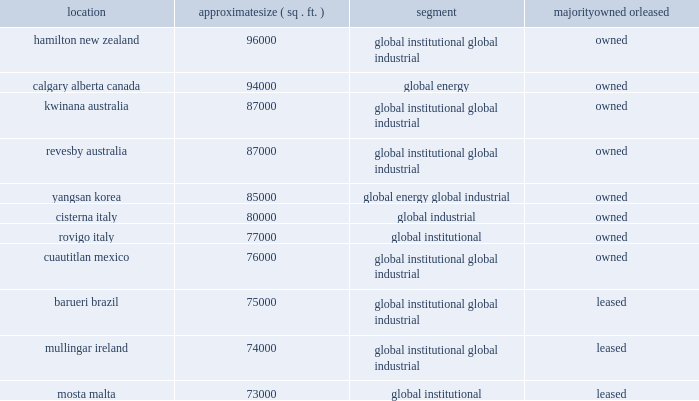Location approximate size ( sq .
Ft. ) segment majority owned or leased .
Generally , our manufacturing facilities are adequate to meet our existing in-house production needs .
We continue to invest in our plant sites to maintain viable operations and to add capacity as necessary to meet business imperatives .
Most of our manufacturing plants also serve as distribution centers .
In addition , we operate distribution centers around the world , most of which are leased , and utilize third party logistics service providers to facilitate the distribution of our products and services .
At year end 2016 ecolab 2019s corporate headquarters was comprised of three adjacent multi-storied buildings located in downtown st .
Paul , minnesota .
The main 19-story building was constructed to our specifications and is leased through june 30 , 2018 .
The second building is leased through 2019 .
The company intends to vacate the current leased buildings in 2018 .
The third building is owned .
Ecolab acquired the 17-story north tower from the travelers indemnity company in downtown st .
Paul , minnesota on august 4 , 2015 .
This building became the corporate headquarters in 2017 .
A 90 acre campus in eagan , minnesota is owned and provides for future growth .
The eagan facility houses a significant research and development center , a data center and training facilities as well as several of our administrative functions .
We also have a significant business presence in naperville , illinois , where our water and paper operating segment maintain their principal administrative offices and research center .
As discussed in part ii , item 8 , note 6 , 201cdebt and interest 201d of this form 10-k , the company acquired the beneficial interest in the trust owning these facilities during 2015 .
Our energy operating segment maintains administrative and research facilities in sugar land , texas and additional research facilities in fresno , texas .
In december 2013 , we announced the construction of a new 133000 square-foot headquarters building adjacent to the existing sugar land operations which was completed in early 2016 and renovation of the existing 45000 square-foot research facilities in sugar land .
Significant regional administrative and/or research facilities are located in leiden , netherlands , campinas , brazil , and pune , india , which we own , and in monheim , germany , singapore , shanghai , china , and zurich , switzerland , which we lease .
We also have a network of small leased sales offices in the united states and , to a lesser extent , in other parts of the world .
Item 3 .
Legal proceedings .
Discussion of legal proceedings is incorporated by reference from part ii , item 8 , note 15 , 201ccommitments and contingencies , 201d of this form 10-k and should be considered an integral part of part i , item 3 , 201clegal proceedings . 201d other environmental-related legal proceedings are discussed at part i , item 1 ( c ) above , under the heading 201cenvironmental and regulatory considerations 201d and is incorporated herein by reference .
Item 4 .
Mine safety disclosures .
Not applicable. .
How many square feet are leased by the company? 
Computations: ((75000 + 74000) + 73000)
Answer: 222000.0. 